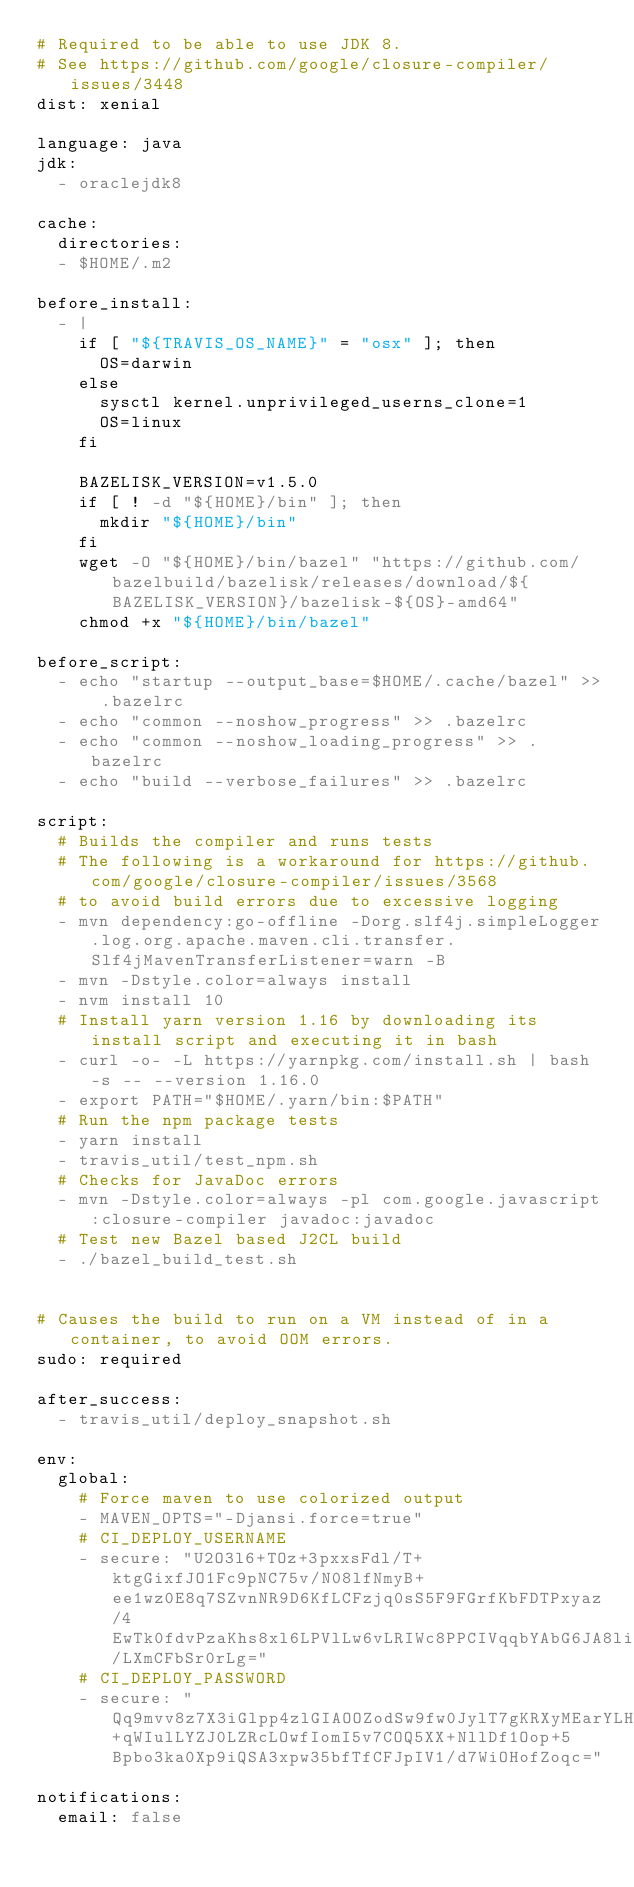<code> <loc_0><loc_0><loc_500><loc_500><_YAML_># Required to be able to use JDK 8.
# See https://github.com/google/closure-compiler/issues/3448
dist: xenial

language: java
jdk:
  - oraclejdk8

cache:
  directories:
  - $HOME/.m2

before_install:
  - |
    if [ "${TRAVIS_OS_NAME}" = "osx" ]; then
      OS=darwin
    else
      sysctl kernel.unprivileged_userns_clone=1
      OS=linux
    fi

    BAZELISK_VERSION=v1.5.0
    if [ ! -d "${HOME}/bin" ]; then
      mkdir "${HOME}/bin"
    fi
    wget -O "${HOME}/bin/bazel" "https://github.com/bazelbuild/bazelisk/releases/download/${BAZELISK_VERSION}/bazelisk-${OS}-amd64"
    chmod +x "${HOME}/bin/bazel"

before_script:
  - echo "startup --output_base=$HOME/.cache/bazel" >> .bazelrc
  - echo "common --noshow_progress" >> .bazelrc
  - echo "common --noshow_loading_progress" >> .bazelrc
  - echo "build --verbose_failures" >> .bazelrc

script:
  # Builds the compiler and runs tests
  # The following is a workaround for https://github.com/google/closure-compiler/issues/3568
  # to avoid build errors due to excessive logging
  - mvn dependency:go-offline -Dorg.slf4j.simpleLogger.log.org.apache.maven.cli.transfer.Slf4jMavenTransferListener=warn -B
  - mvn -Dstyle.color=always install
  - nvm install 10
  # Install yarn version 1.16 by downloading its install script and executing it in bash
  - curl -o- -L https://yarnpkg.com/install.sh | bash -s -- --version 1.16.0
  - export PATH="$HOME/.yarn/bin:$PATH"
  # Run the npm package tests
  - yarn install
  - travis_util/test_npm.sh
  # Checks for JavaDoc errors
  - mvn -Dstyle.color=always -pl com.google.javascript:closure-compiler javadoc:javadoc
  # Test new Bazel based J2CL build
  - ./bazel_build_test.sh


# Causes the build to run on a VM instead of in a container, to avoid OOM errors.
sudo: required

after_success:
  - travis_util/deploy_snapshot.sh

env:
  global:
    # Force maven to use colorized output
    - MAVEN_OPTS="-Djansi.force=true"
    # CI_DEPLOY_USERNAME
    - secure: "U2O3l6+TOz+3pxxsFdl/T+ktgGixfJO1Fc9pNC75v/N08lfNmyB+ee1wz0E8q7SZvnNR9D6KfLCFzjq0sS5F9FGrfKbFDTPxyaz/4EwTk0fdvPzaKhs8xl6LPVlLw6vLRIWc8PPCIVqqbYAbG6JA8liBPGbBXD/LXmCFbSr0rLg="
    # CI_DEPLOY_PASSWORD
    - secure: "Qq9mvv8z7X3iGlpp4zlGIAOOZodSw9fw0JylT7gKRXyMEarYLHoBXoNnb6seTxExRKuvSGo8UTvqLA4rg2+qWIulLYZJ0LZRcLOwfIomI5v7COQ5XX+NllDf1Oop+5Bpbo3ka0Xp9iQSA3xpw35bfTfCFJpIV1/d7WiOHofZoqc="

notifications:
  email: false
</code> 